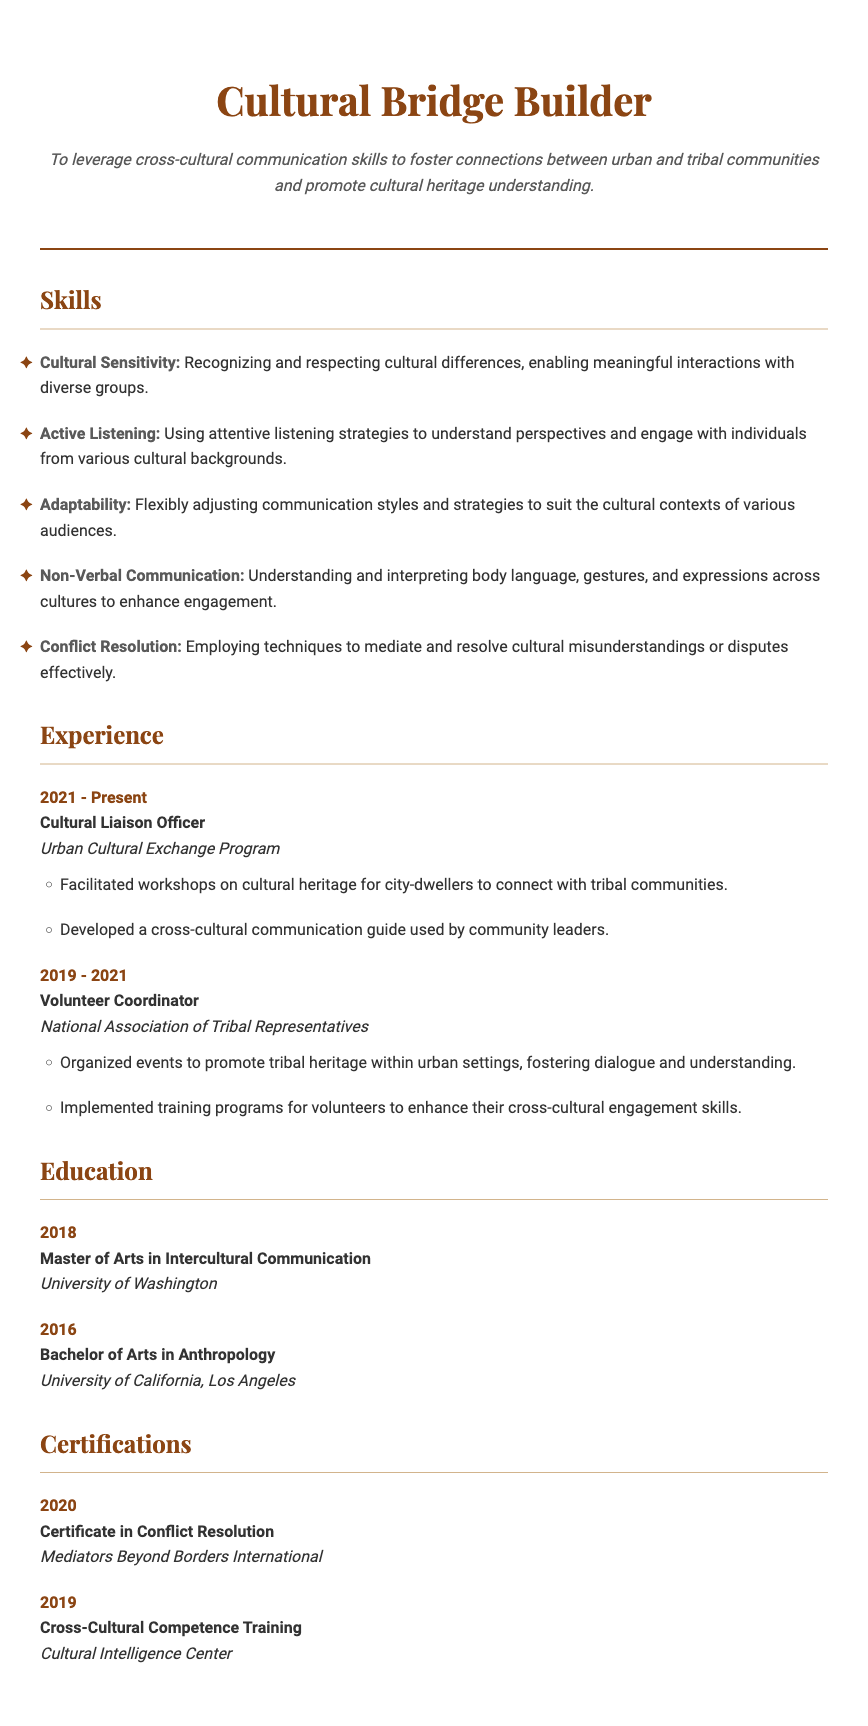What is the title of the CV? The title of the CV is prominently displayed at the top, which identifies the individual's role as a cultural liaison.
Answer: Cultural Bridge Builder When did the individual serve as a Cultural Liaison Officer? The document specifies the dates of employment for each role, highlighting the current position's timeframe.
Answer: 2021 - Present What university did the individual attend for their Master's degree? The document includes educational background with institutions noted for each degree earned.
Answer: University of Washington What skill is associated with recognizing and respecting cultural differences? The skills section lists various skill sets linked to cross-cultural communication and engagement, with specific descriptions for each.
Answer: Cultural Sensitivity How many achievements are listed under the Cultural Liaison Officer experience? The achievements are detailed in bullet points, which can be counted for each role under the experience section.
Answer: 2 What certification did the individual earn in 2020? The certifications section details the types and dates of certifications obtained, citing specific institutions as well.
Answer: Certificate in Conflict Resolution What degree does the individual hold related to Anthropology? The education section provides details on academic qualifications, including degree types and fields of study.
Answer: Bachelor of Arts in Anthropology How many years did the individual work as a Volunteer Coordinator? The experience section outlines the timeline for roles held, which can be calculated to determine specific durations.
Answer: 2 years What skill involves using attentive listening strategies? The skills section articulates various competencies related to communication, with specific examples of their application.
Answer: Active Listening 